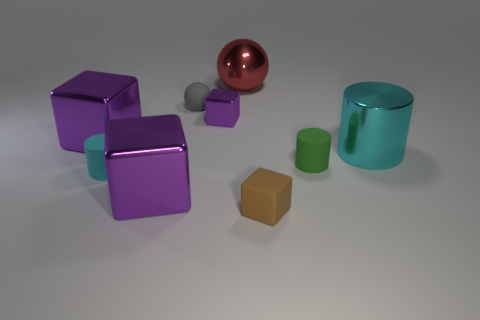What materials do the objects in the image appear to be made of? The objects in the image seem to be rendered with different materials. The cylinders (green and turquoise) and the sphere look like they might be made of glossy plastic or polished metal due to their reflective surfaces, while the cubes appear to have a matte finish, possibly representing either a matte plastic or painted metal. 